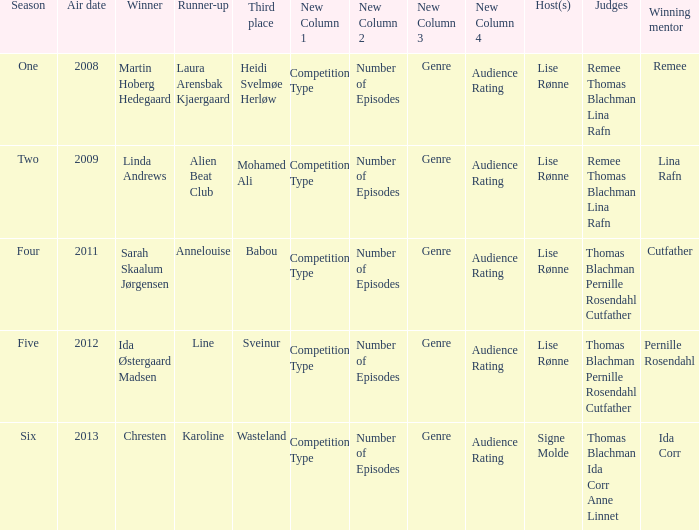Which season did Ida Corr win? Six. 